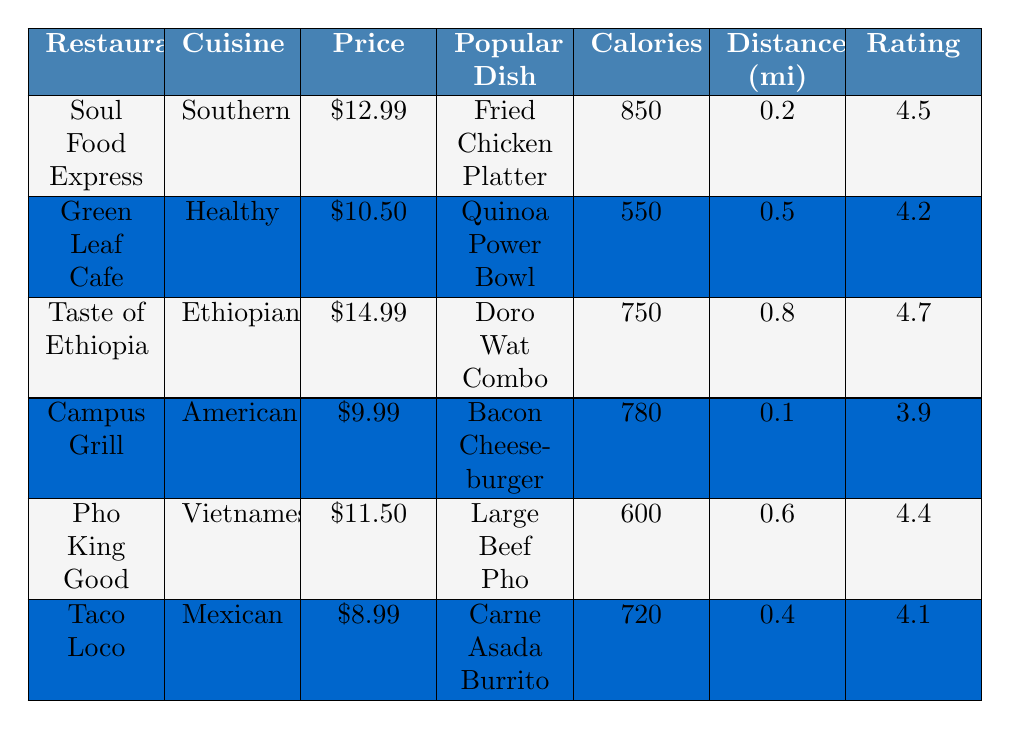What is the average price of the meals listed? The average price can be calculated by summing the average meal prices of all six restaurants: (12.99 + 10.50 + 14.99 + 9.99 + 11.50 + 8.99) = 68.96. There are 6 restaurants, so we divide by 6 to get 68.96 / 6 = 11.49.
Answer: 11.49 Which restaurant has the highest student rating? By reviewing the student ratings, Taste of Ethiopia has the highest rating at 4.7.
Answer: 4.7 Does Campus Grill have vegetarian options? According to the table, Campus Grill does have vegetarian options indicated by "true."
Answer: Yes What is the distance from Taco Loco to the dorms? Taco Loco's distance from the dorms is listed as 0.4 miles.
Answer: 0.4 miles Which restaurant offers a popular dish with the highest calories? Comparing the popular dishes, the Fried Chicken Platter at Soul Food Express has the highest calories at 850.
Answer: 850 If I wanted the healthiest popular dish by calories, which one should I choose? The Quinoa Power Bowl from Green Leaf Cafe has the lowest calories at 550, making it the healthiest choice based on calories.
Answer: Quinoa Power Bowl What is the average distance of all the restaurants from the dorms? The distances are 0.2, 0.5, 0.8, 0.1, 0.6, and 0.4 miles. Summing these gives 0.2 + 0.5 + 0.8 + 0.1 + 0.6 + 0.4 = 2.6 miles, and dividing by 6 gives the average distance of 2.6 / 6 = 0.433 miles.
Answer: 0.433 miles Which cuisine type has the most student-rated options above 4.0? The restaurant options that have ratings above 4.0 are Soul Food Express, Green Leaf Cafe, Taste of Ethiopia, and Pho King Good, which are classified as Southern, Healthy, Ethiopian, and Vietnamese cuisines respectively. This makes a total of four options across those cuisine types.
Answer: 4 options Is there a restaurant with both vegetarian and halal options? Yes, both Green Leaf Cafe and Taste of Ethiopia offer vegetarian and halal options.
Answer: Yes Which restaurant has the most protein in its popular dish? The Fried Chicken Platter from Soul Food Express has the most protein at 45 grams, more than any of the other dishes listed.
Answer: 45 grams 